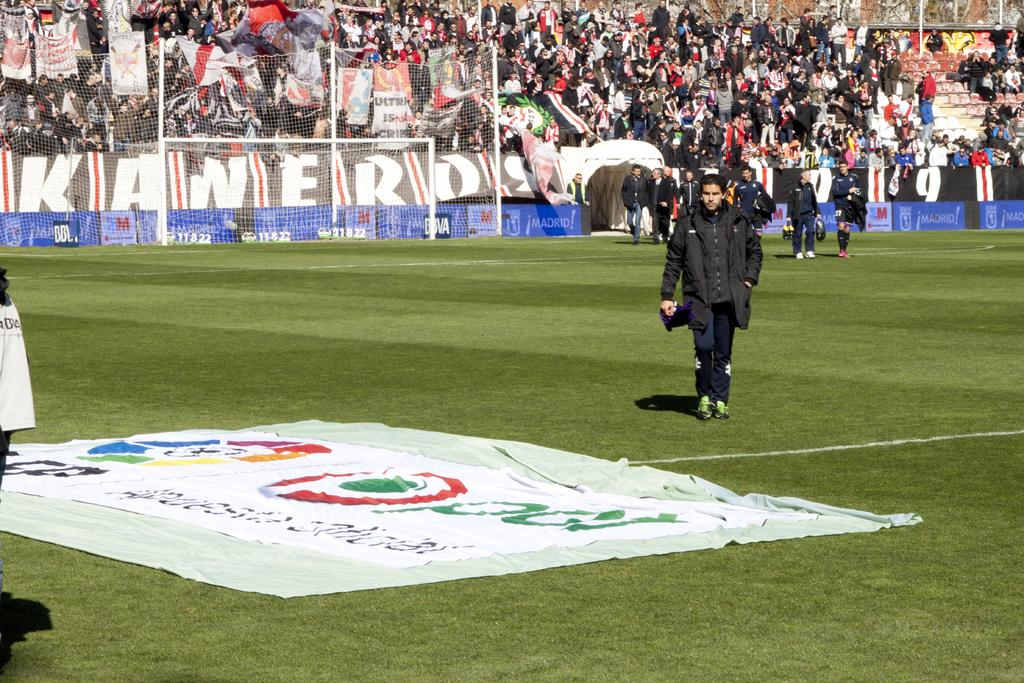What are the people in the image doing? The people in the image are walking on the ground. What can be seen hanging or displayed in the image? There is a banner with text and images in the image. What is visible in the background of the image? There is a net and spectators in the background of the image. What type of pin is holding the banner in place in the image? There is no pin mentioned or visible in the image; the banner is simply hanging or displayed. 